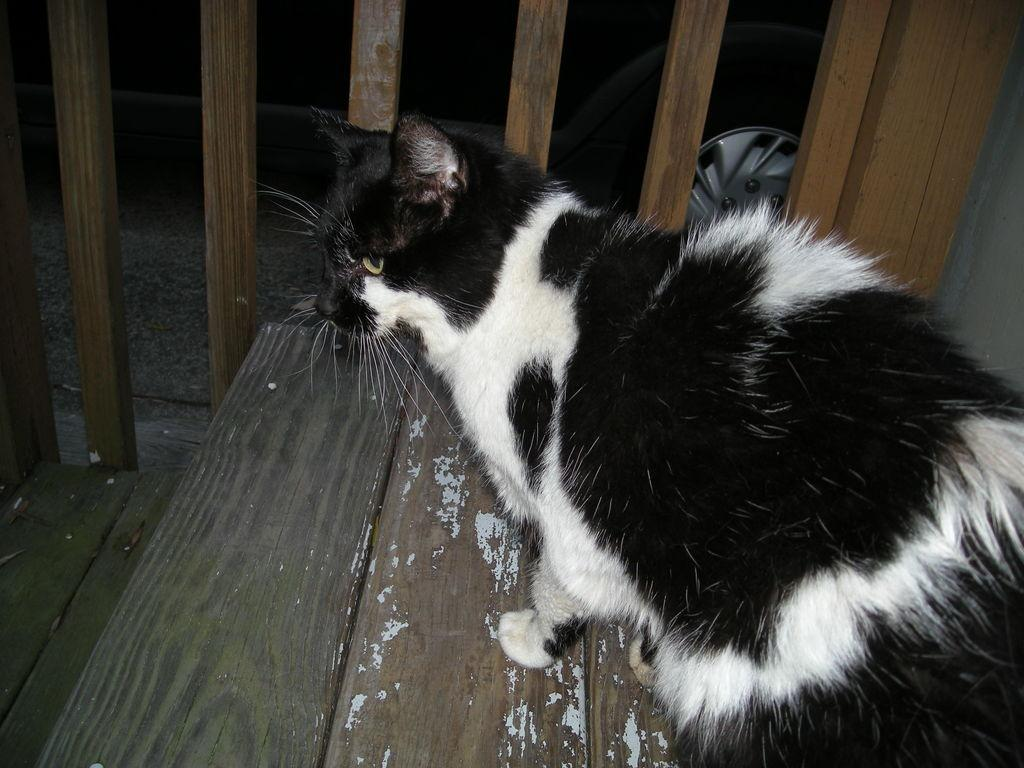What type of staircase is visible in the image? There is a wooden staircase in the image. What else can be seen in the image besides the staircase? There is an object in the image. What is the main subject of the image? The image features a cat as the main subject. What type of work is the cat doing in the image? The image does not depict the cat performing any work; it is simply the main subject of the image. 